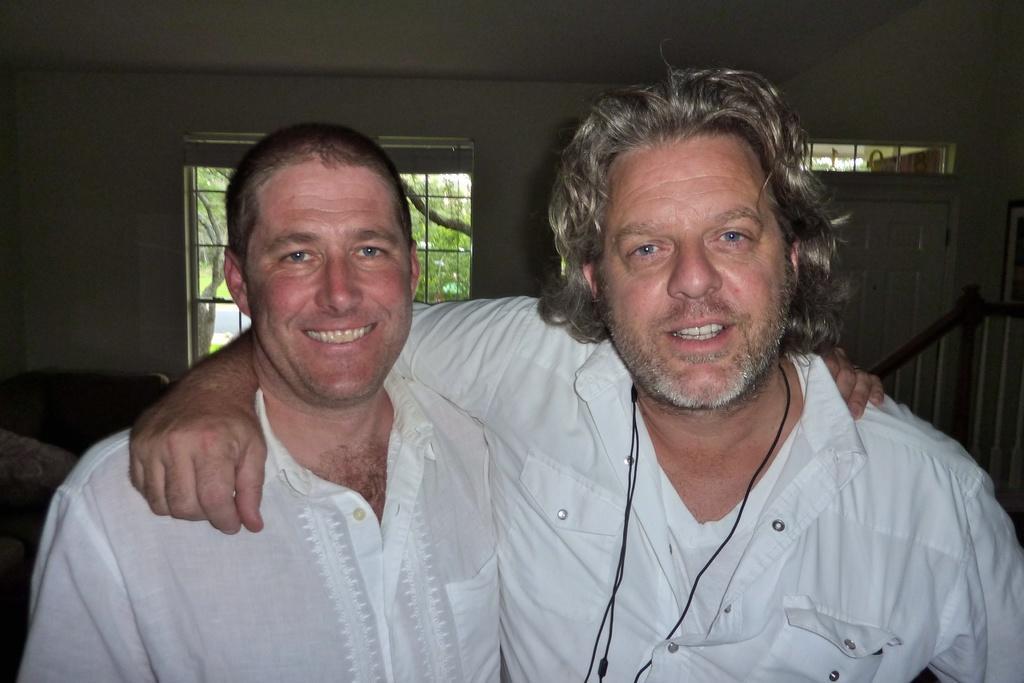Could you give a brief overview of what you see in this image? This image consists of a two men. Both are wearing the white shirts. In the background, we can see a wall along with a door and a window. At the top, there is a roof. On the right, we can see a handrail. On the left, it looks like a sofa. 